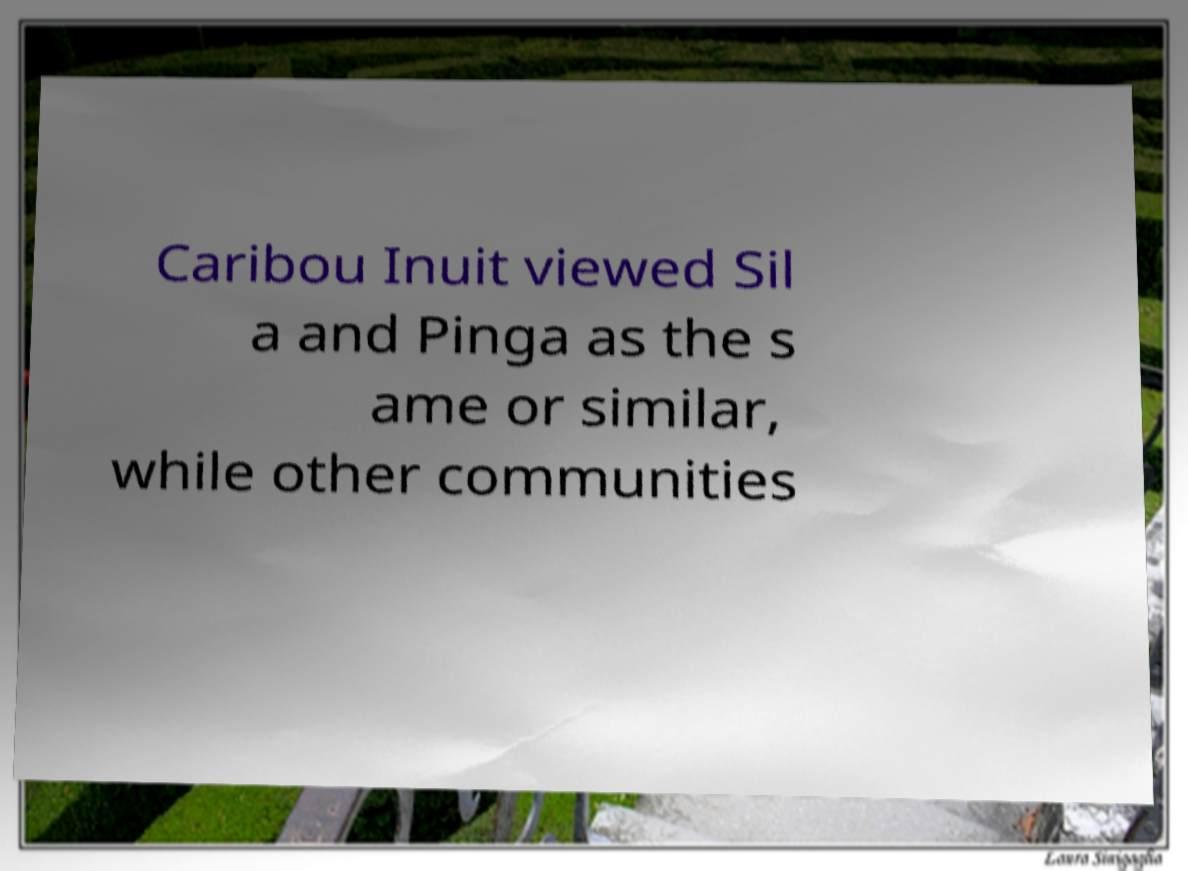Could you assist in decoding the text presented in this image and type it out clearly? Caribou Inuit viewed Sil a and Pinga as the s ame or similar, while other communities 